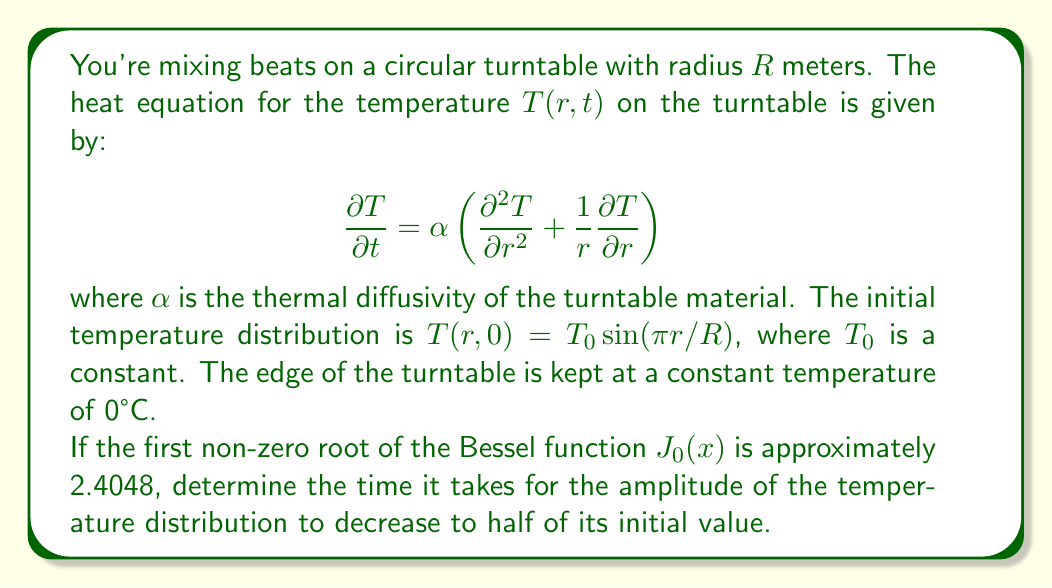Show me your answer to this math problem. Let's approach this step-by-step:

1) The general solution to the heat equation in cylindrical coordinates with radial symmetry is:

   $$T(r,t) = \sum_{n=1}^{\infty} A_n J_0(\lambda_n r/R) e^{-\alpha \lambda_n^2 t/R^2}$$

   where $J_0$ is the Bessel function of the first kind of order zero, and $\lambda_n$ are the roots of $J_0(x)=0$.

2) Given the initial condition $T(r,0) = T_0 \sin(\pi r/R)$, we need only the first term of the series (n=1):

   $$T(r,t) \approx A_1 J_0(\lambda_1 r/R) e^{-\alpha \lambda_1^2 t/R^2}$$

3) The first non-zero root of $J_0(x)$ is given as $\lambda_1 \approx 2.4048$.

4) At $t=0$, the amplitude of the temperature distribution is $T_0$. We want to find the time $t$ when this amplitude has decreased to $T_0/2$.

5) This occurs when:

   $$e^{-\alpha \lambda_1^2 t/R^2} = 1/2$$

6) Taking the natural logarithm of both sides:

   $$-\alpha \lambda_1^2 t/R^2 = \ln(1/2) = -\ln(2)$$

7) Solving for $t$:

   $$t = \frac{R^2 \ln(2)}{\alpha \lambda_1^2} = \frac{R^2 \ln(2)}{\alpha (2.4048)^2}$$

This is the time it takes for the amplitude to decrease to half its initial value.
Answer: The time it takes for the amplitude of the temperature distribution to decrease to half of its initial value is:

$$t = \frac{R^2 \ln(2)}{\alpha (2.4048)^2}$$

where $R$ is the radius of the turntable and $\alpha$ is the thermal diffusivity of the turntable material. 